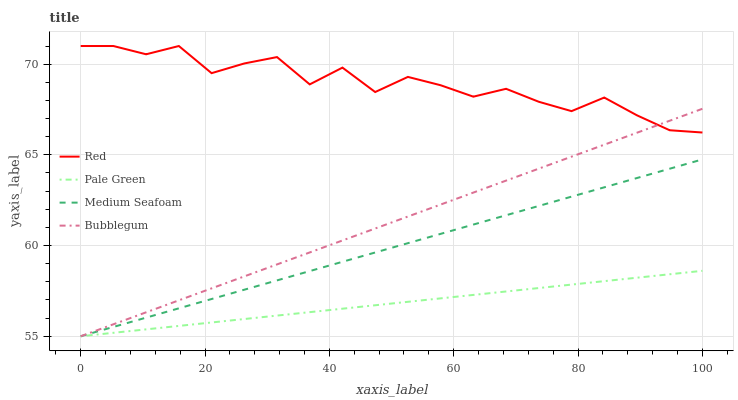Does Pale Green have the minimum area under the curve?
Answer yes or no. Yes. Does Red have the maximum area under the curve?
Answer yes or no. Yes. Does Medium Seafoam have the minimum area under the curve?
Answer yes or no. No. Does Medium Seafoam have the maximum area under the curve?
Answer yes or no. No. Is Medium Seafoam the smoothest?
Answer yes or no. Yes. Is Red the roughest?
Answer yes or no. Yes. Is Pale Green the smoothest?
Answer yes or no. No. Is Pale Green the roughest?
Answer yes or no. No. Does Bubblegum have the lowest value?
Answer yes or no. Yes. Does Red have the lowest value?
Answer yes or no. No. Does Red have the highest value?
Answer yes or no. Yes. Does Medium Seafoam have the highest value?
Answer yes or no. No. Is Pale Green less than Red?
Answer yes or no. Yes. Is Red greater than Medium Seafoam?
Answer yes or no. Yes. Does Pale Green intersect Bubblegum?
Answer yes or no. Yes. Is Pale Green less than Bubblegum?
Answer yes or no. No. Is Pale Green greater than Bubblegum?
Answer yes or no. No. Does Pale Green intersect Red?
Answer yes or no. No. 